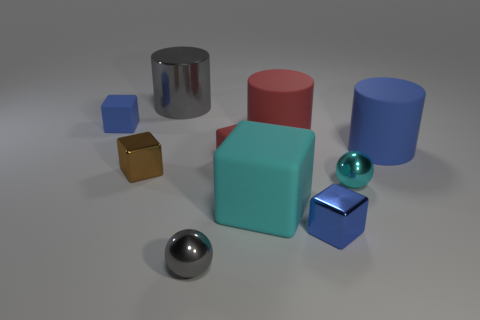What color is the thing that is behind the large red cylinder and on the left side of the big metal object?
Offer a terse response. Blue. How many other things are the same size as the cyan block?
Your response must be concise. 3. Is the size of the red rubber cylinder the same as the metallic object that is behind the tiny red rubber block?
Give a very brief answer. Yes. The matte cube that is the same size as the gray metal cylinder is what color?
Your response must be concise. Cyan. How big is the cyan metal object?
Give a very brief answer. Small. Is the blue block that is in front of the tiny cyan shiny sphere made of the same material as the small gray object?
Your answer should be very brief. Yes. Is the shape of the tiny brown shiny thing the same as the small blue rubber object?
Keep it short and to the point. Yes. What is the shape of the blue matte object in front of the blue rubber thing that is left of the large object behind the tiny blue rubber cube?
Provide a short and direct response. Cylinder. Is the shape of the rubber thing that is on the left side of the gray metallic ball the same as the gray object that is in front of the big red thing?
Offer a very short reply. No. Are there any other big cylinders that have the same material as the red cylinder?
Offer a very short reply. Yes. 